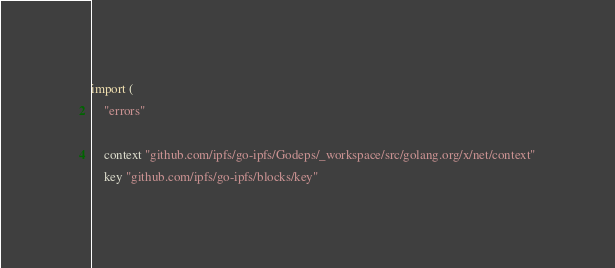<code> <loc_0><loc_0><loc_500><loc_500><_Go_>import (
	"errors"

	context "github.com/ipfs/go-ipfs/Godeps/_workspace/src/golang.org/x/net/context"
	key "github.com/ipfs/go-ipfs/blocks/key"</code> 